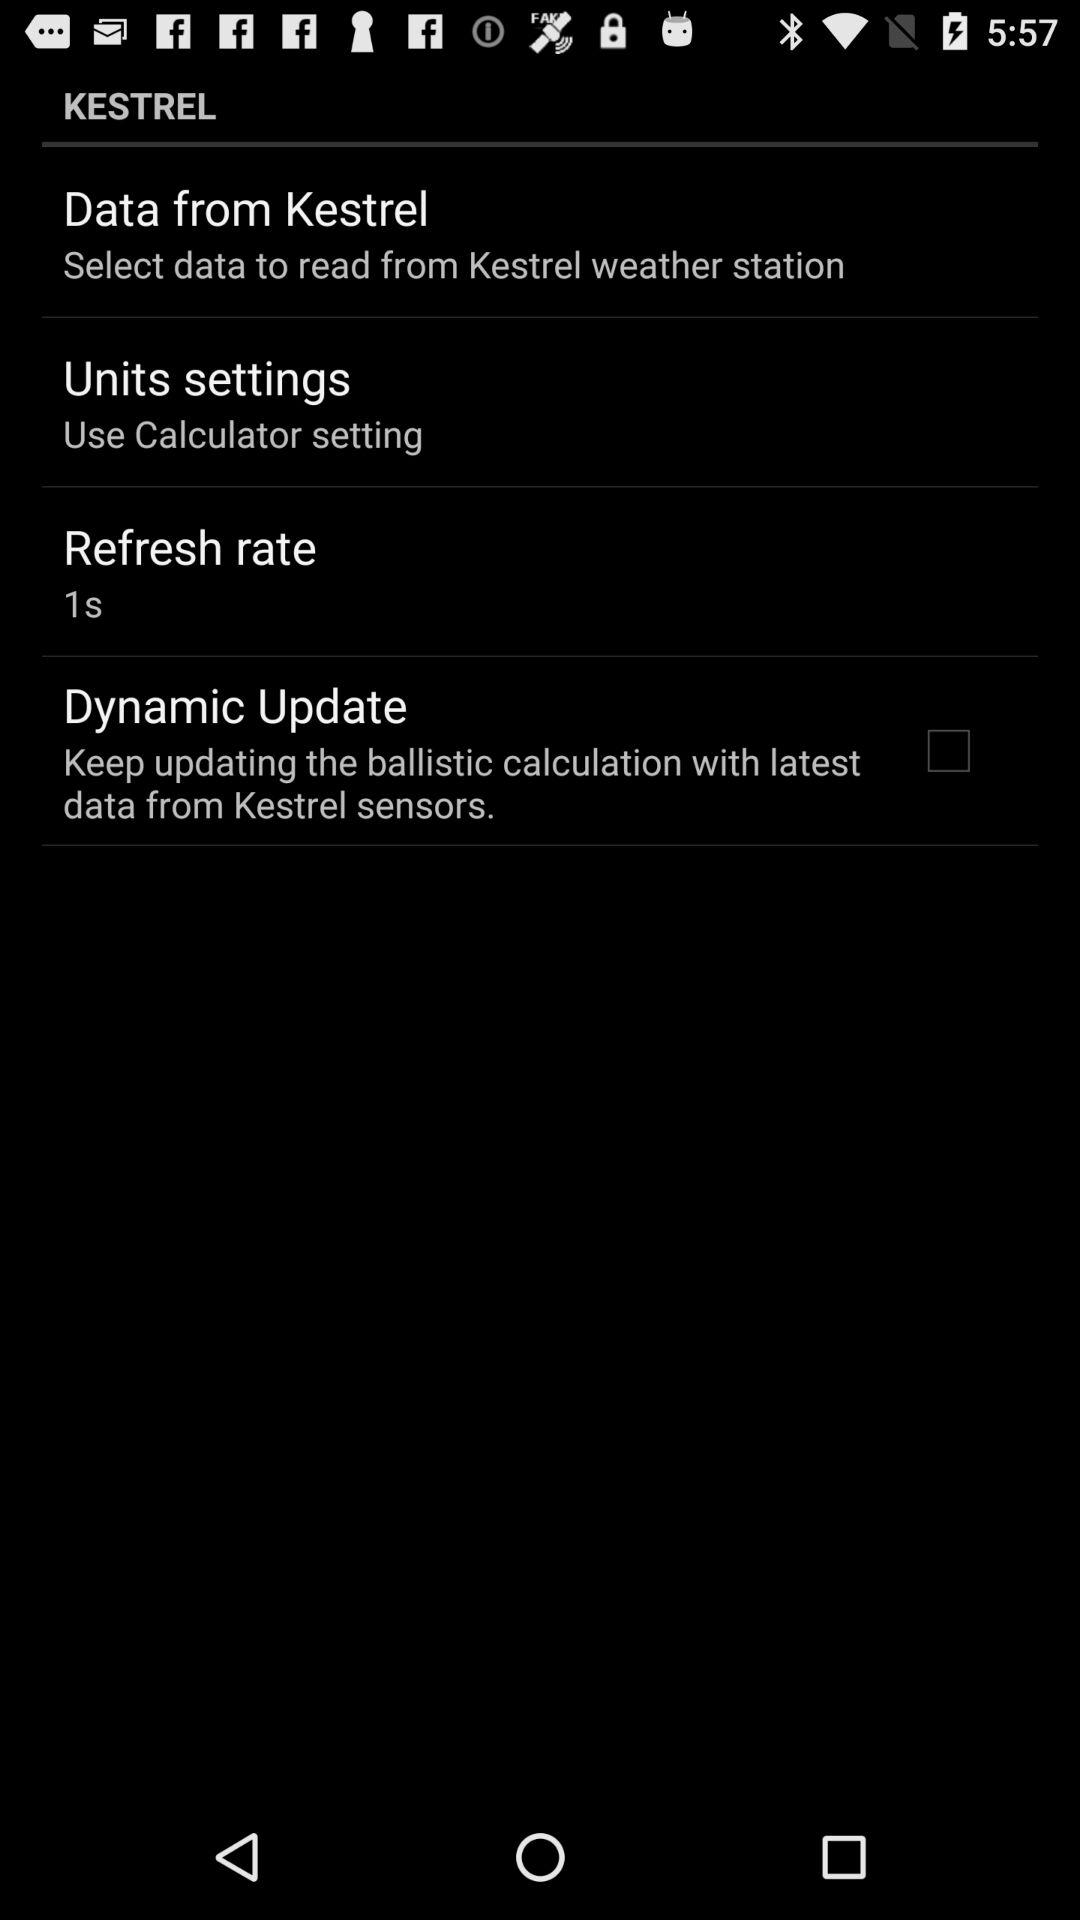What is the description of "Units settings"? The description of "Units settings" is "Use Calculator setting". 